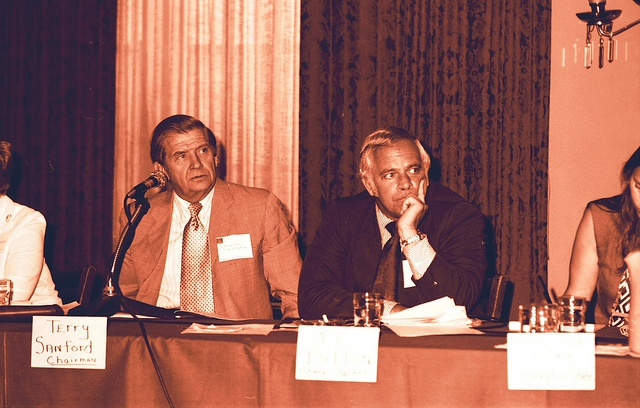Describe the objects in this image and their specific colors. I can see people in black, salmon, ivory, and brown tones, people in black, purple, salmon, and brown tones, people in black, maroon, brown, salmon, and tan tones, people in black, ivory, and tan tones, and tie in black, beige, tan, and salmon tones in this image. 